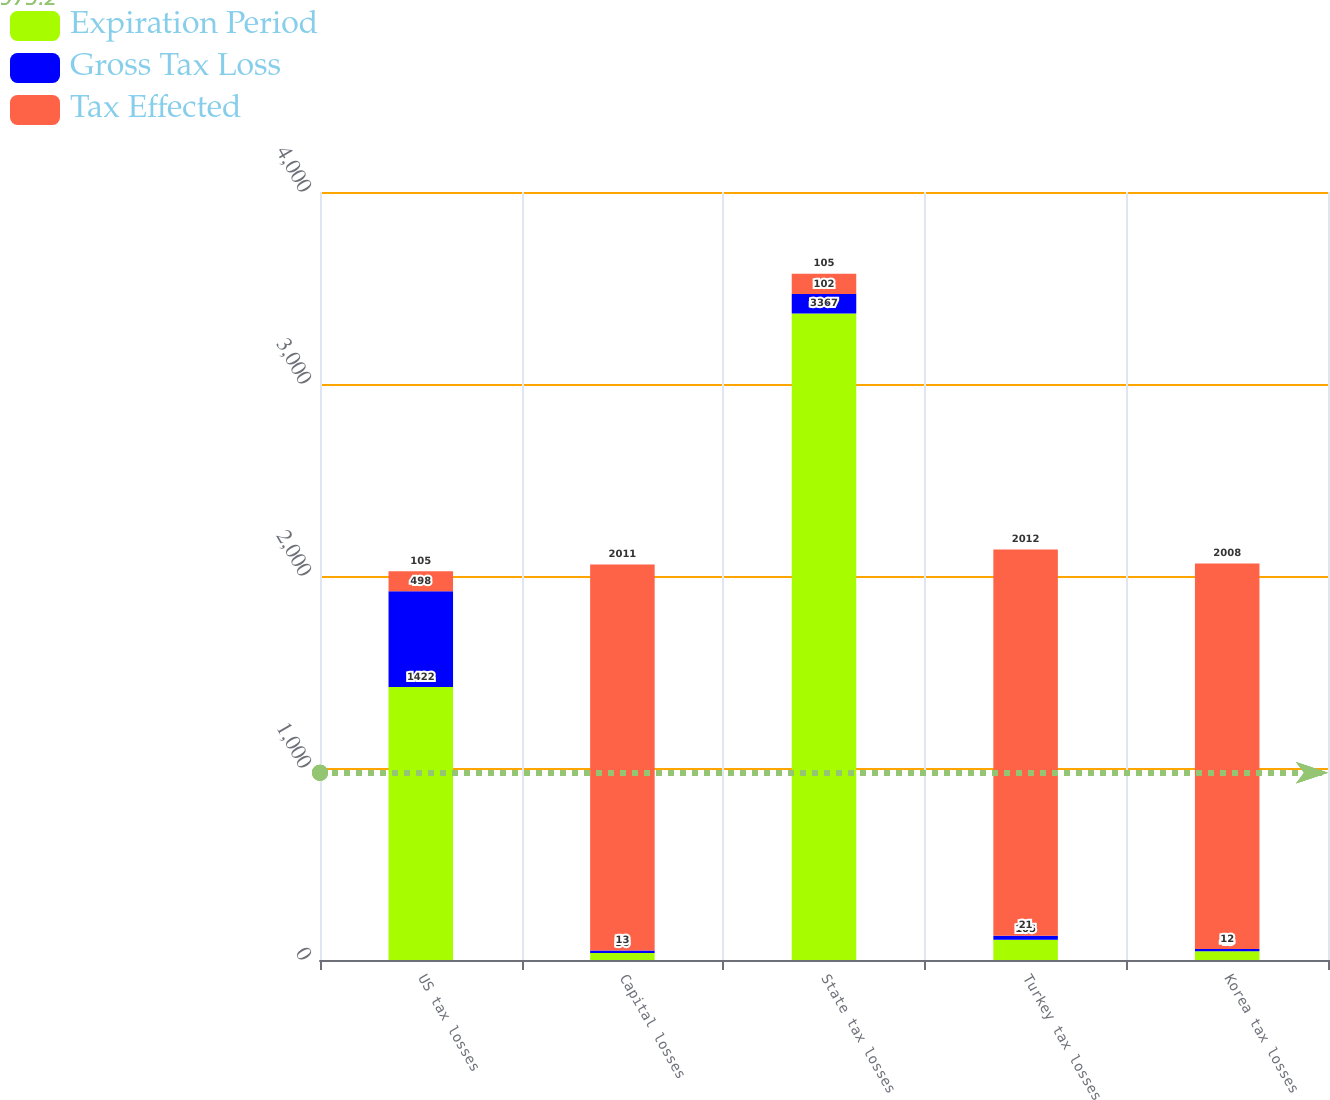Convert chart to OTSL. <chart><loc_0><loc_0><loc_500><loc_500><stacked_bar_chart><ecel><fcel>US tax losses<fcel>Capital losses<fcel>State tax losses<fcel>Turkey tax losses<fcel>Korea tax losses<nl><fcel>Expiration Period<fcel>1422<fcel>36<fcel>3367<fcel>105<fcel>45<nl><fcel>Gross Tax Loss<fcel>498<fcel>13<fcel>102<fcel>21<fcel>12<nl><fcel>Tax Effected<fcel>105<fcel>2011<fcel>105<fcel>2012<fcel>2008<nl></chart> 